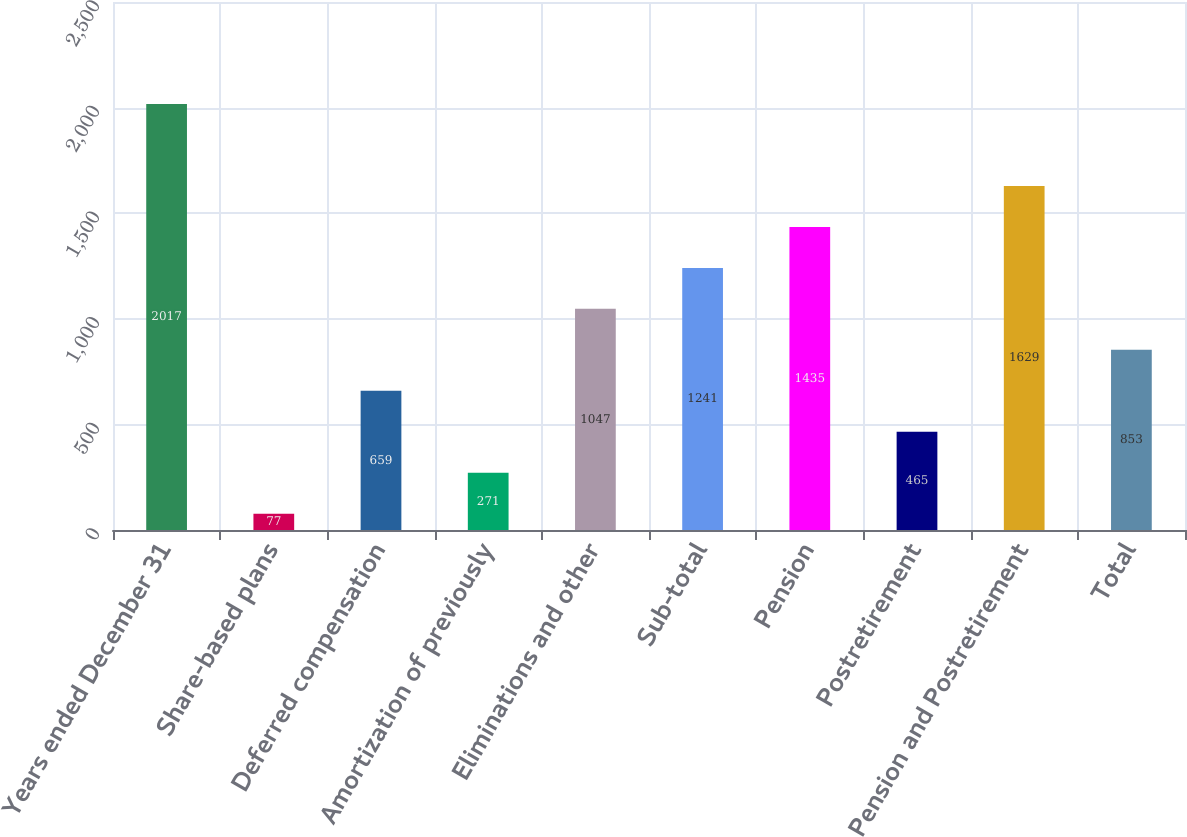Convert chart. <chart><loc_0><loc_0><loc_500><loc_500><bar_chart><fcel>Years ended December 31<fcel>Share-based plans<fcel>Deferred compensation<fcel>Amortization of previously<fcel>Eliminations and other<fcel>Sub-total<fcel>Pension<fcel>Postretirement<fcel>Pension and Postretirement<fcel>Total<nl><fcel>2017<fcel>77<fcel>659<fcel>271<fcel>1047<fcel>1241<fcel>1435<fcel>465<fcel>1629<fcel>853<nl></chart> 